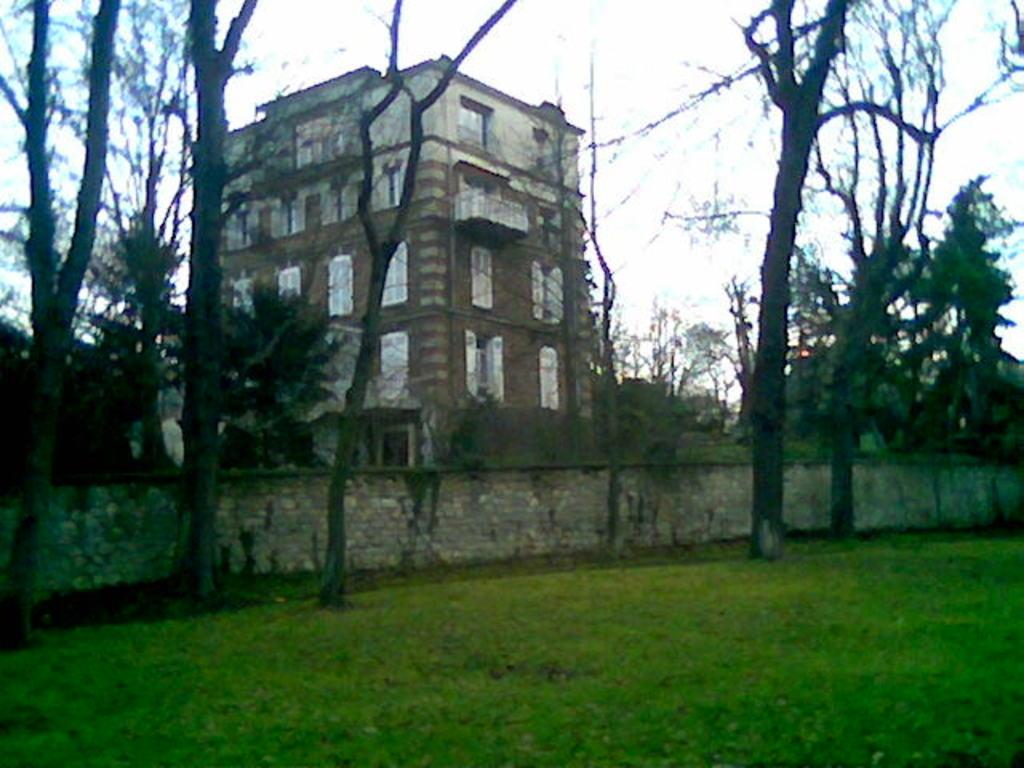What type of structure is present in the image? There is a building in the image. What feature can be seen on the building? The building has windows. What type of vegetation is present in the image? There are trees in the image. What type of barrier is present in the image? There is a fencing wall in the image. What type of ground cover is visible in the image? Green grass is visible in the image. What is the color of the sky in the image? The sky appears to be white in color. What type of soup is being served in the image? There is no soup present in the image. What season is depicted in the image? The provided facts do not indicate a specific season, so it cannot be determined from the image. 